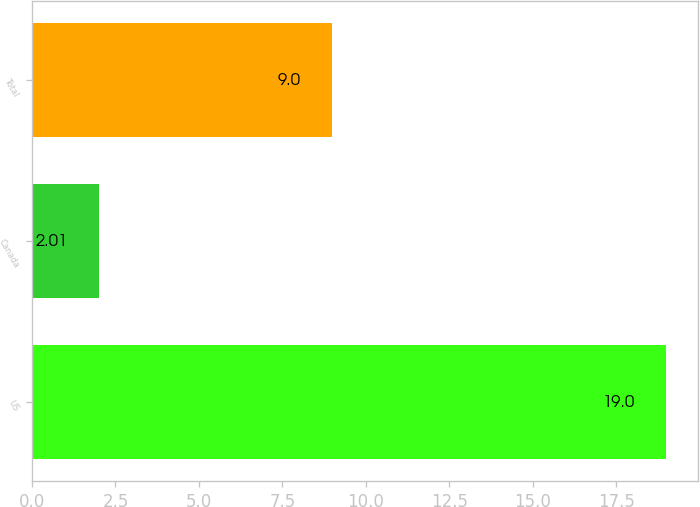Convert chart. <chart><loc_0><loc_0><loc_500><loc_500><bar_chart><fcel>US<fcel>Canada<fcel>Total<nl><fcel>19<fcel>2.01<fcel>9<nl></chart> 